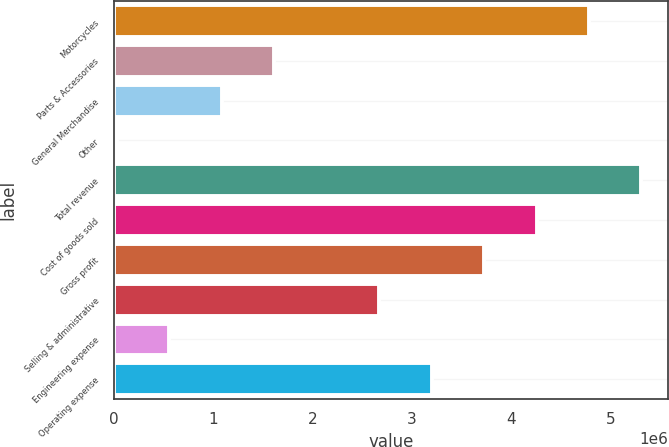<chart> <loc_0><loc_0><loc_500><loc_500><bar_chart><fcel>Motorcycles<fcel>Parts & Accessories<fcel>General Merchandise<fcel>Other<fcel>Total revenue<fcel>Cost of goods sold<fcel>Gross profit<fcel>Selling & administrative<fcel>Engineering expense<fcel>Operating expense<nl><fcel>4.78047e+06<fcel>1.61086e+06<fcel>1.08259e+06<fcel>26050<fcel>5.30874e+06<fcel>4.25221e+06<fcel>3.72394e+06<fcel>2.6674e+06<fcel>554319<fcel>3.19567e+06<nl></chart> 